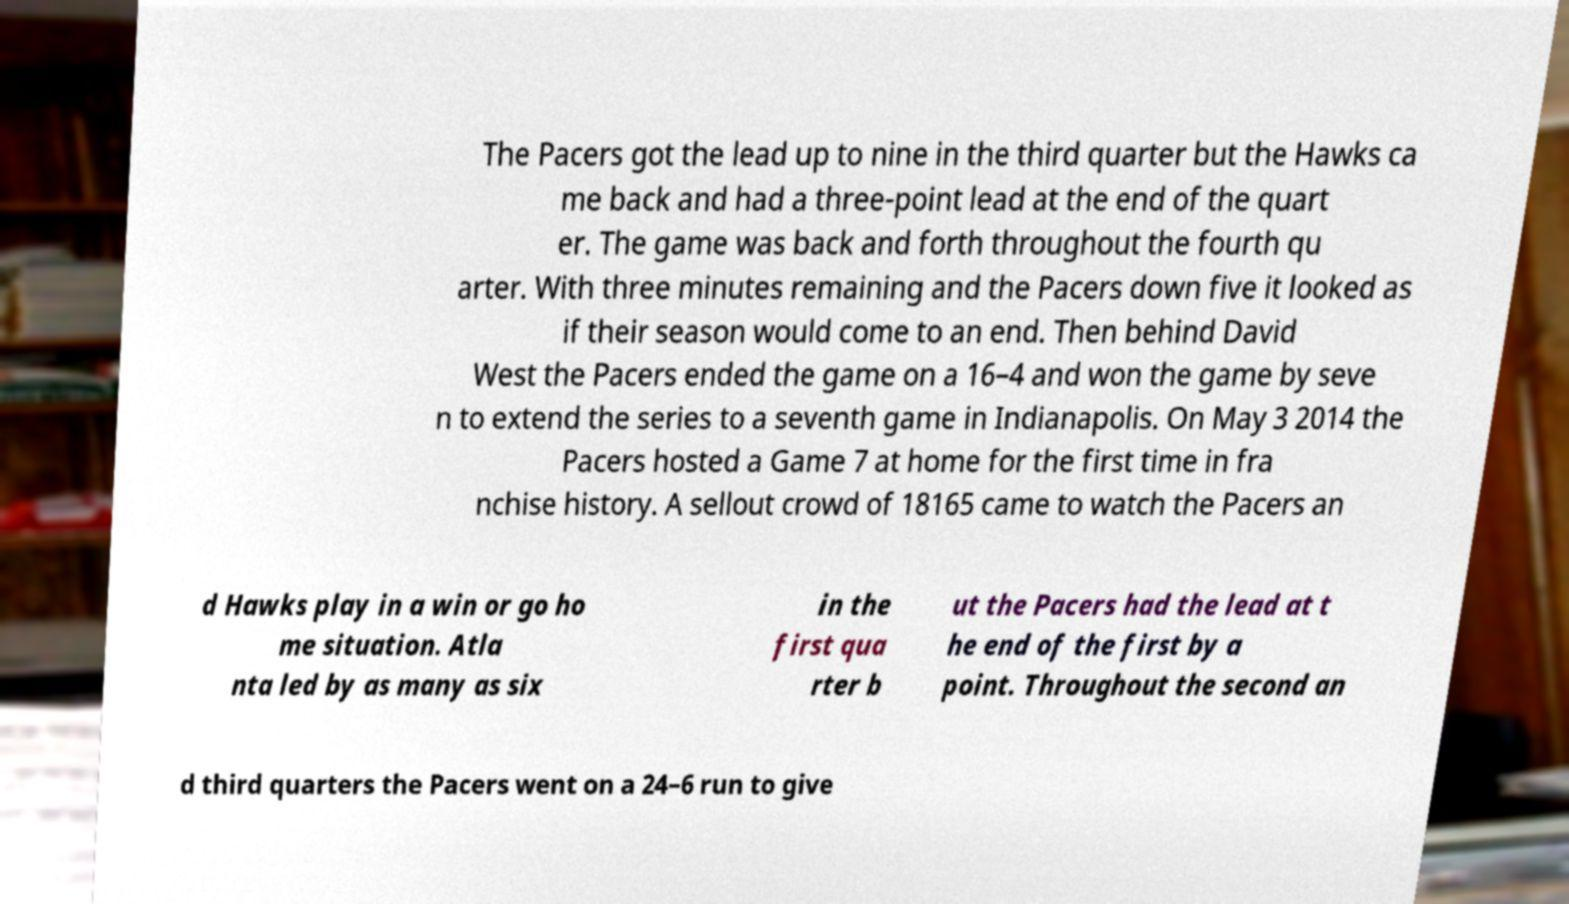For documentation purposes, I need the text within this image transcribed. Could you provide that? The Pacers got the lead up to nine in the third quarter but the Hawks ca me back and had a three-point lead at the end of the quart er. The game was back and forth throughout the fourth qu arter. With three minutes remaining and the Pacers down five it looked as if their season would come to an end. Then behind David West the Pacers ended the game on a 16–4 and won the game by seve n to extend the series to a seventh game in Indianapolis. On May 3 2014 the Pacers hosted a Game 7 at home for the first time in fra nchise history. A sellout crowd of 18165 came to watch the Pacers an d Hawks play in a win or go ho me situation. Atla nta led by as many as six in the first qua rter b ut the Pacers had the lead at t he end of the first by a point. Throughout the second an d third quarters the Pacers went on a 24–6 run to give 